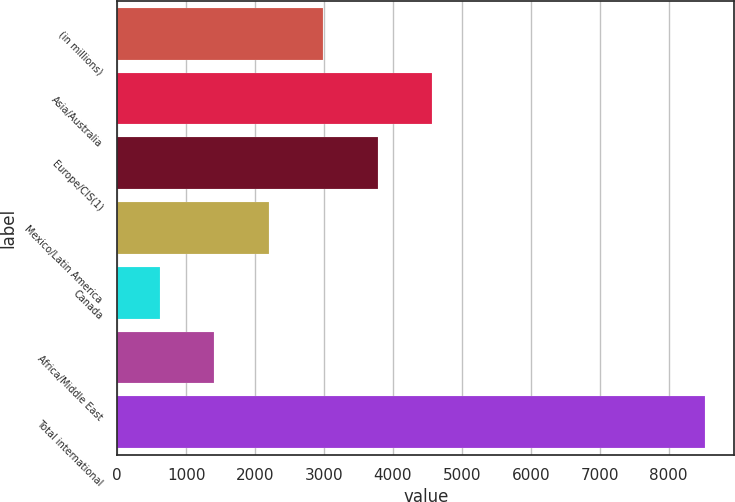Convert chart to OTSL. <chart><loc_0><loc_0><loc_500><loc_500><bar_chart><fcel>(in millions)<fcel>Asia/Australia<fcel>Europe/CIS(1)<fcel>Mexico/Latin America<fcel>Canada<fcel>Africa/Middle East<fcel>Total international<nl><fcel>2990.8<fcel>4572<fcel>3781.4<fcel>2200.2<fcel>619<fcel>1409.6<fcel>8525<nl></chart> 